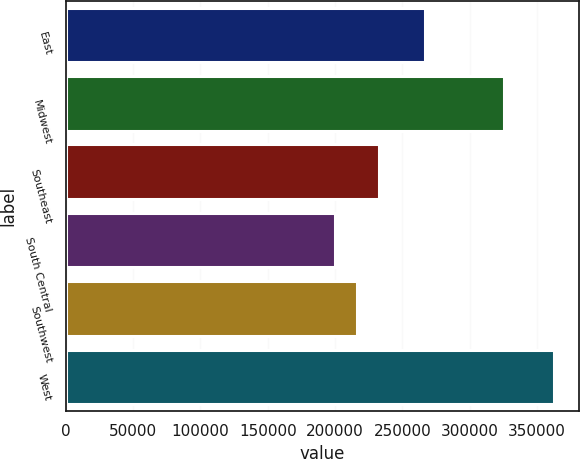<chart> <loc_0><loc_0><loc_500><loc_500><bar_chart><fcel>East<fcel>Midwest<fcel>Southeast<fcel>South Central<fcel>Southwest<fcel>West<nl><fcel>266600<fcel>325300<fcel>232500<fcel>199900<fcel>216200<fcel>362900<nl></chart> 